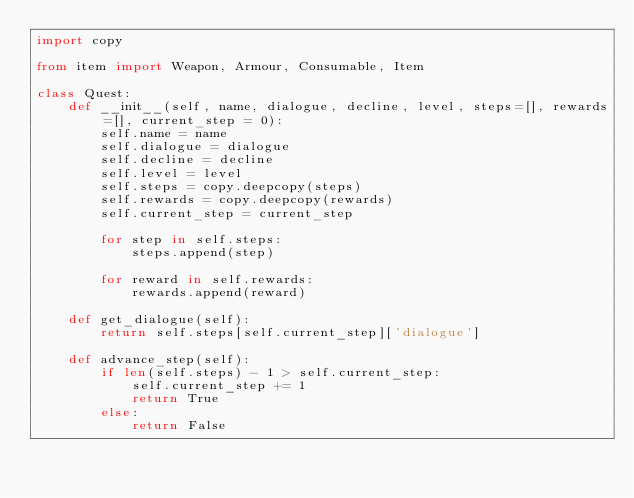<code> <loc_0><loc_0><loc_500><loc_500><_Python_>import copy

from item import Weapon, Armour, Consumable, Item

class Quest:
    def __init__(self, name, dialogue, decline, level, steps=[], rewards=[], current_step = 0):
        self.name = name
        self.dialogue = dialogue
        self.decline = decline
        self.level = level
        self.steps = copy.deepcopy(steps)
        self.rewards = copy.deepcopy(rewards)
        self.current_step = current_step
        
        for step in self.steps:
            steps.append(step)
        
        for reward in self.rewards:
            rewards.append(reward)
    
    def get_dialogue(self):
        return self.steps[self.current_step]['dialogue']
    
    def advance_step(self):
        if len(self.steps) - 1 > self.current_step:
            self.current_step += 1
            return True
        else:
            return False</code> 